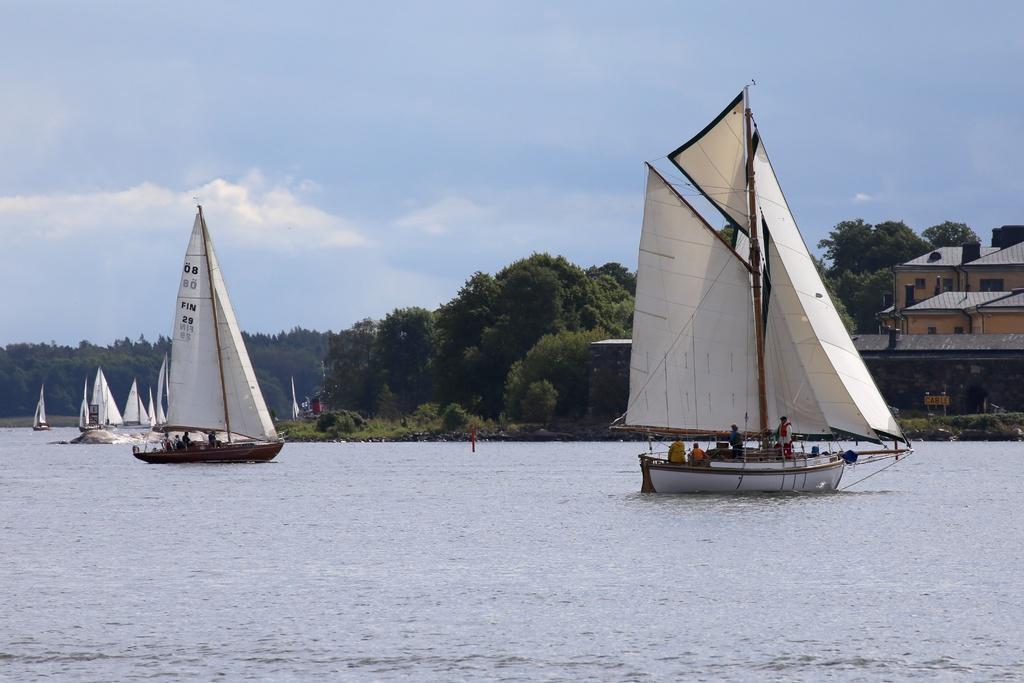Could you give a brief overview of what you see in this image? In this image we can see some people on boats placed in water. On the right side of the image we can see buildings with windows and a sign board with some text. In the center of the image we can see a group of trees. At the top of the image we can see the sky. 